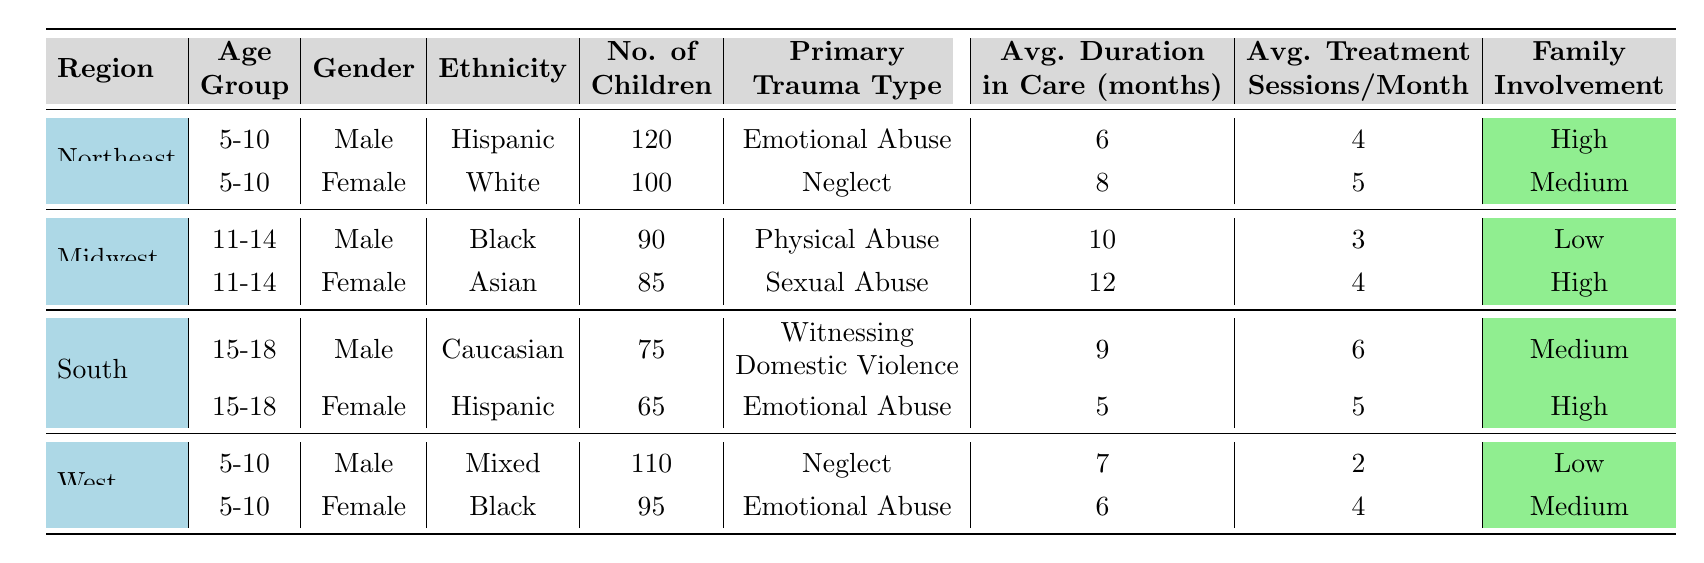What is the total number of children in trauma-informed care programs in the Northeast? In the Northeast, there are two groups of children: 120 males and 100 females. Adding these together gives 120 + 100 = 220 children.
Answer: 220 What is the average duration in care for the children in the Midwest? In the Midwest, the average durations are 10 months for males and 12 months for females. To find the average, sum the durations (10 + 12) and divide by the number of groups (2), which results in (10 + 12) / 2 = 22 / 2 = 11 months.
Answer: 11 months Which gender has a higher number of children receiving trauma-informed care in the South? In the South, there are 75 males and 65 females. Comparing these figures, males (75) have a higher count than females (65).
Answer: Male What is the primary trauma type for the highest number of children in the West? In the West, there are 110 children with Neglect and 95 with Emotional Abuse. The highest number is for Neglect (110 children).
Answer: Neglect Is there any group in the table with low family involvement? In the table, the Midwest male group and the West male group both list low family involvement. Therefore, the answer is yes.
Answer: Yes What is the average number of treatment sessions per month for children aged 15-18 in the South? In the South, the average treatment sessions for males are 6 and for females are 5. The average is calculated as (6 + 5) / 2 = 11 / 2 = 5.5.
Answer: 5.5 Which region has the highest number of children in the 5-10 age group? In the 5-10 age group, Northeast has 120 males, and West has 110 males; the Northeast has the highest at 120 children.
Answer: Northeast What trauma type is most common among 11-14-year-old females? Among 11-14-year-old females, the primary trauma type is Sexual Abuse, as indicated for the Midwest region.
Answer: Sexual Abuse What is the total number of children across all regions aged 15-18? In the South age group of 15-18, there are 75 males and 65 females. Adding these gives 75 + 65 = 140 children in total for that age group.
Answer: 140 How many children in total are in the 5-10 age group across all regions? In the 5-10 age group, there are 120 children in the Northeast (males) and 100 females in the Northeast, and 110 males, 95 females in the West. Thus, the total is 120 + 100 + 110 + 95 = 425.
Answer: 425 